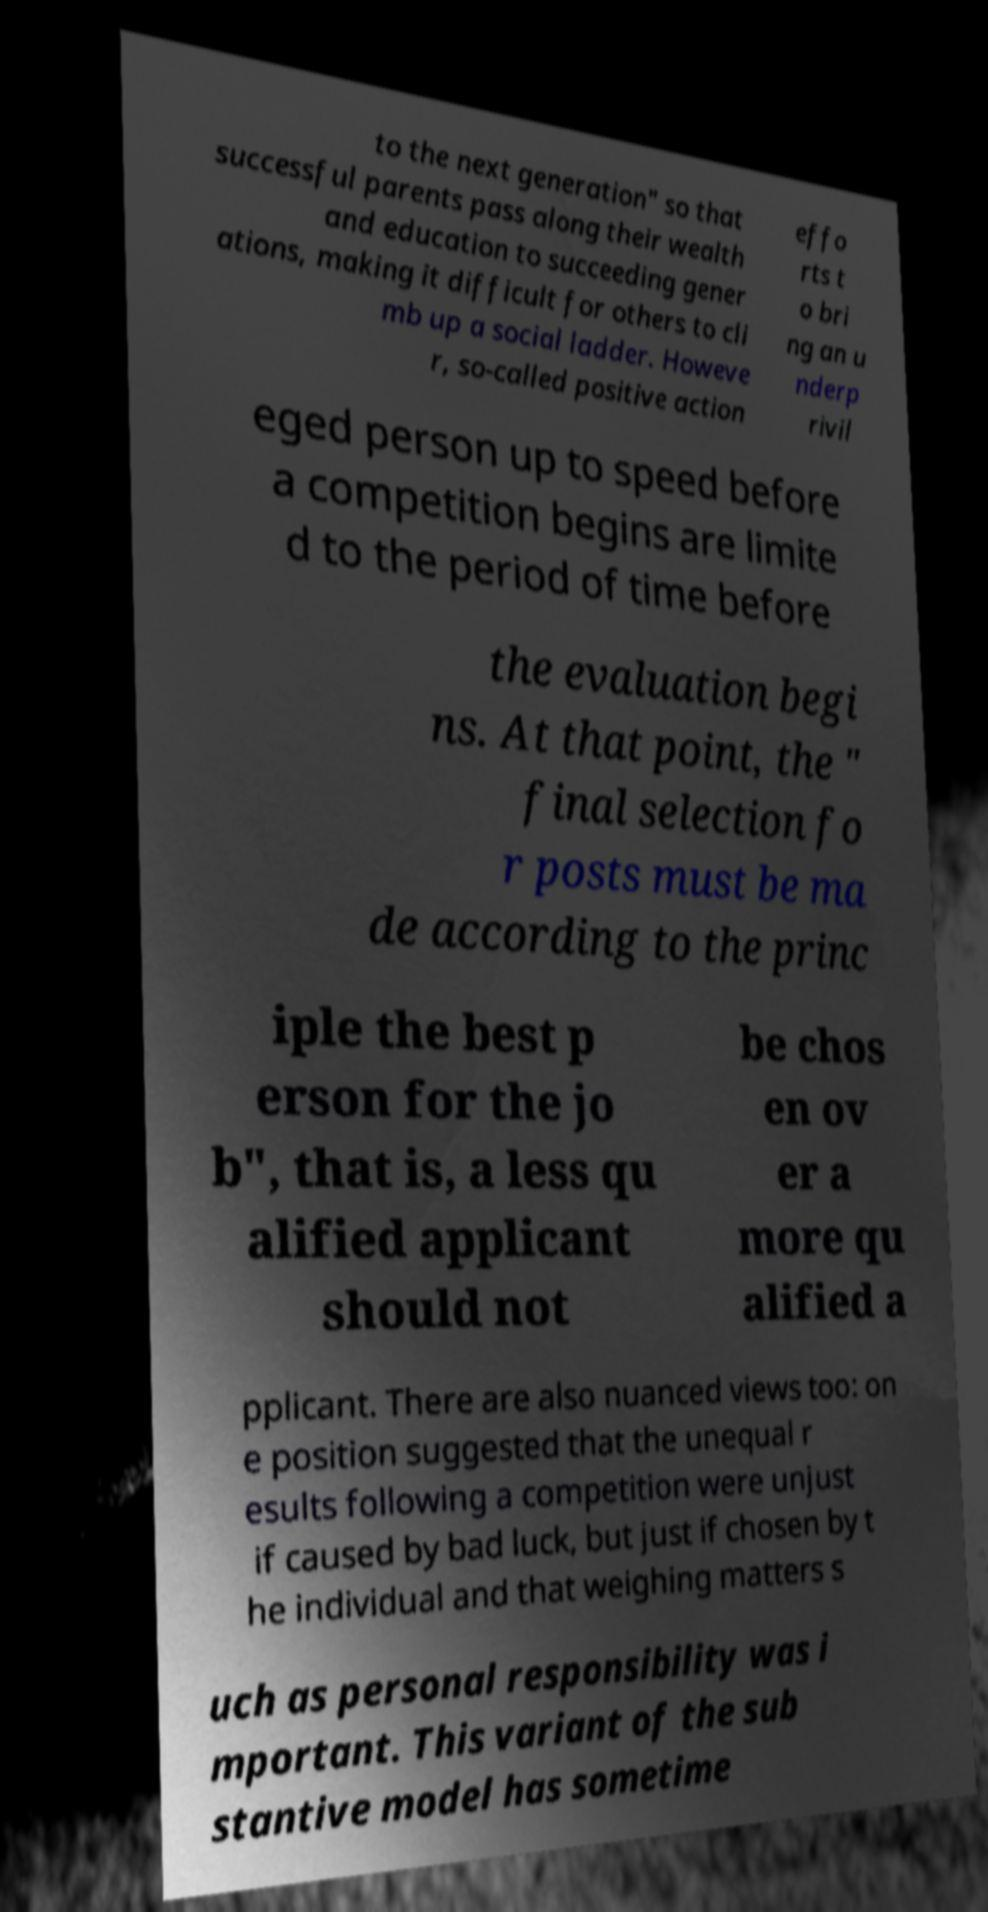Please identify and transcribe the text found in this image. to the next generation" so that successful parents pass along their wealth and education to succeeding gener ations, making it difficult for others to cli mb up a social ladder. Howeve r, so-called positive action effo rts t o bri ng an u nderp rivil eged person up to speed before a competition begins are limite d to the period of time before the evaluation begi ns. At that point, the " final selection fo r posts must be ma de according to the princ iple the best p erson for the jo b", that is, a less qu alified applicant should not be chos en ov er a more qu alified a pplicant. There are also nuanced views too: on e position suggested that the unequal r esults following a competition were unjust if caused by bad luck, but just if chosen by t he individual and that weighing matters s uch as personal responsibility was i mportant. This variant of the sub stantive model has sometime 